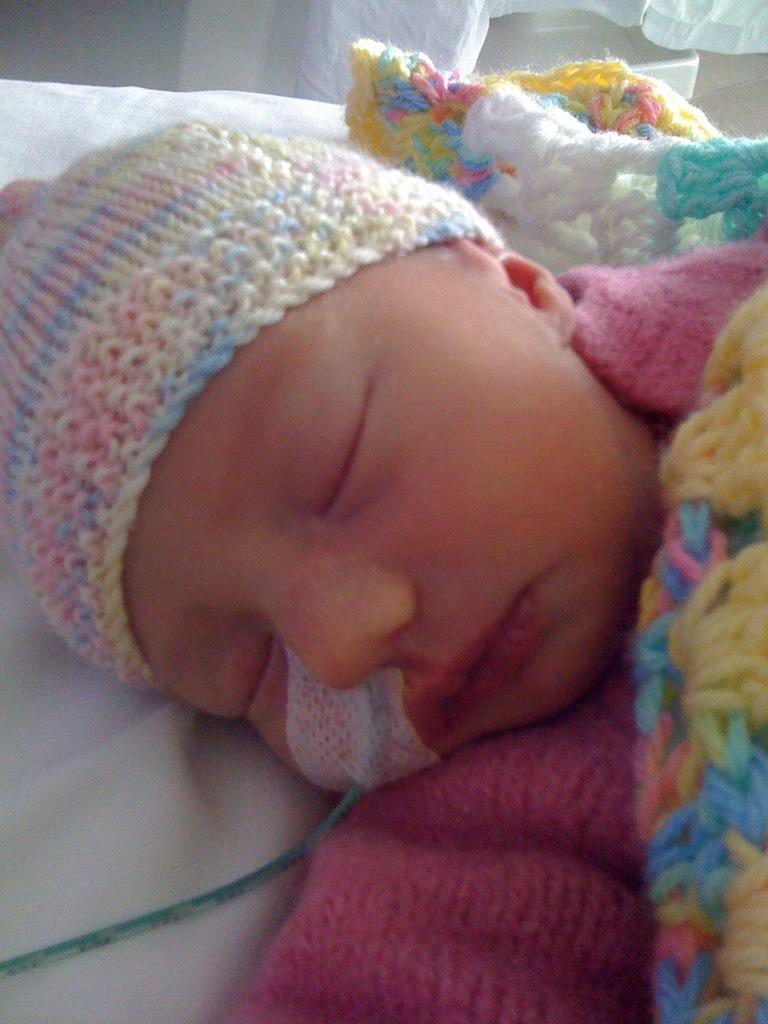Please provide a concise description of this image. In this image I can see a kid wearing a woolen cap. 